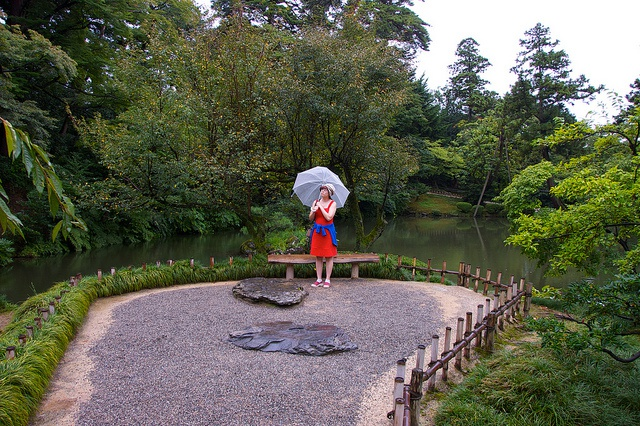Describe the objects in this image and their specific colors. I can see people in black, red, lavender, brown, and lightpink tones, umbrella in black, darkgray, lavender, and gray tones, and bench in black, brown, darkgray, and gray tones in this image. 